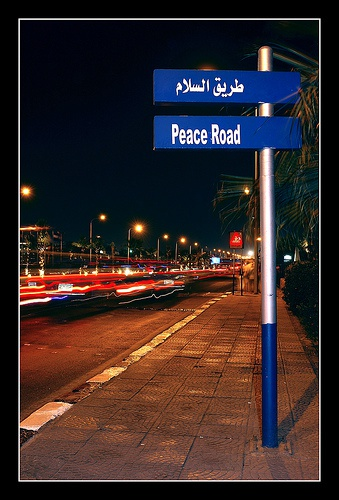Describe the objects in this image and their specific colors. I can see car in black, red, and maroon tones and people in black, maroon, brown, red, and orange tones in this image. 